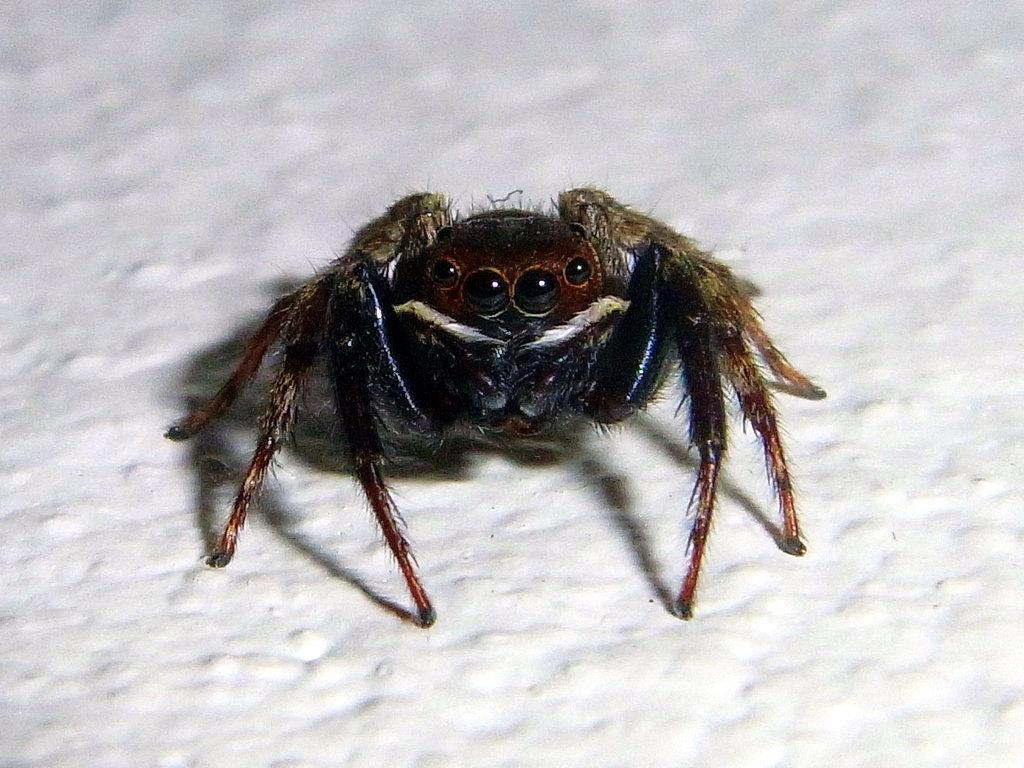What type of creature is present in the image? There is an insect in the image. Where is the insect located in the image? The insect is on a surface. What type of industry is depicted in the image? There is no industry depicted in the image; it features an insect on a surface. What punishment is the insect receiving in the image? There is no punishment being depicted in the image; it simply shows an insect on a surface. 